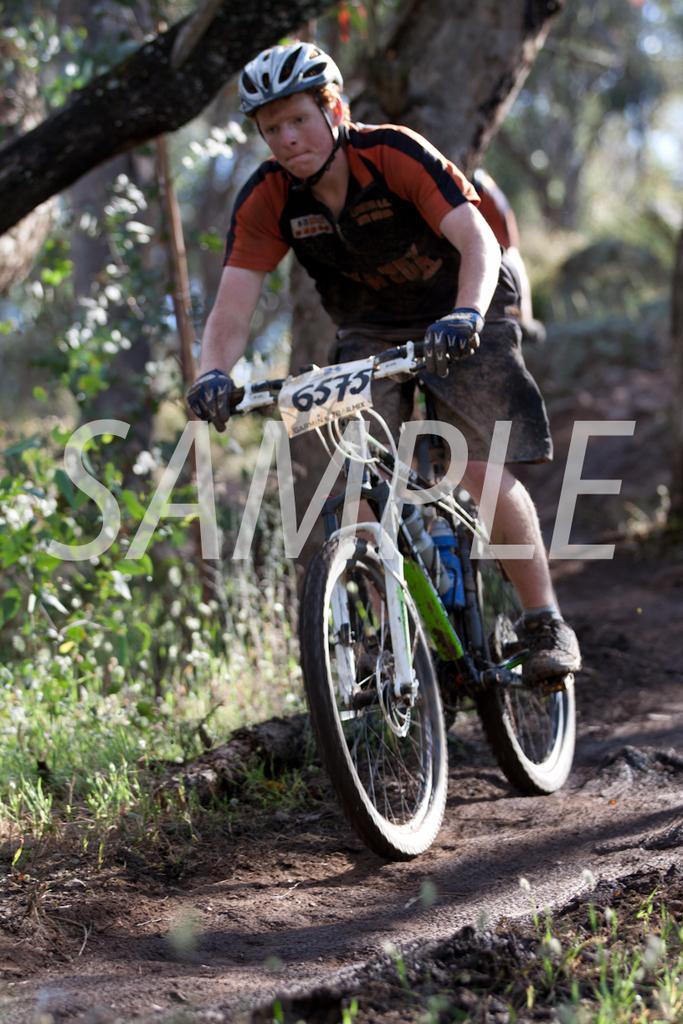How would you summarize this image in a sentence or two? In the image there is a man riding cycle on the sand floor and the background of the man is blur. 